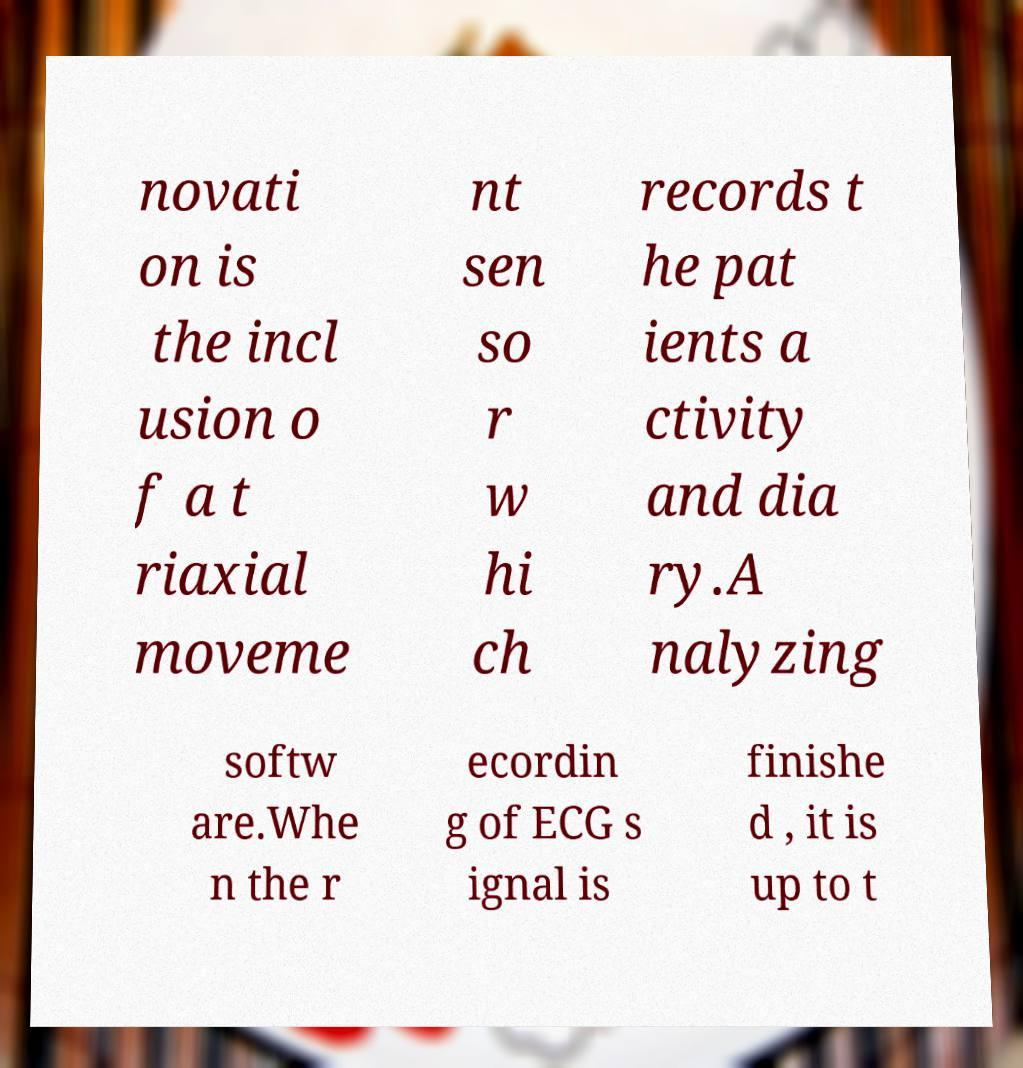Could you assist in decoding the text presented in this image and type it out clearly? novati on is the incl usion o f a t riaxial moveme nt sen so r w hi ch records t he pat ients a ctivity and dia ry.A nalyzing softw are.Whe n the r ecordin g of ECG s ignal is finishe d , it is up to t 